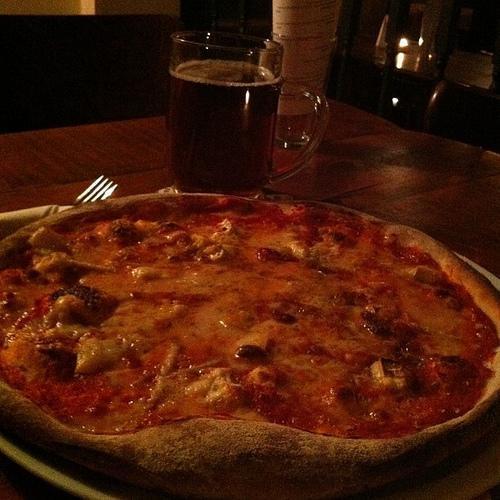How many pizzas are visible?
Give a very brief answer. 1. 